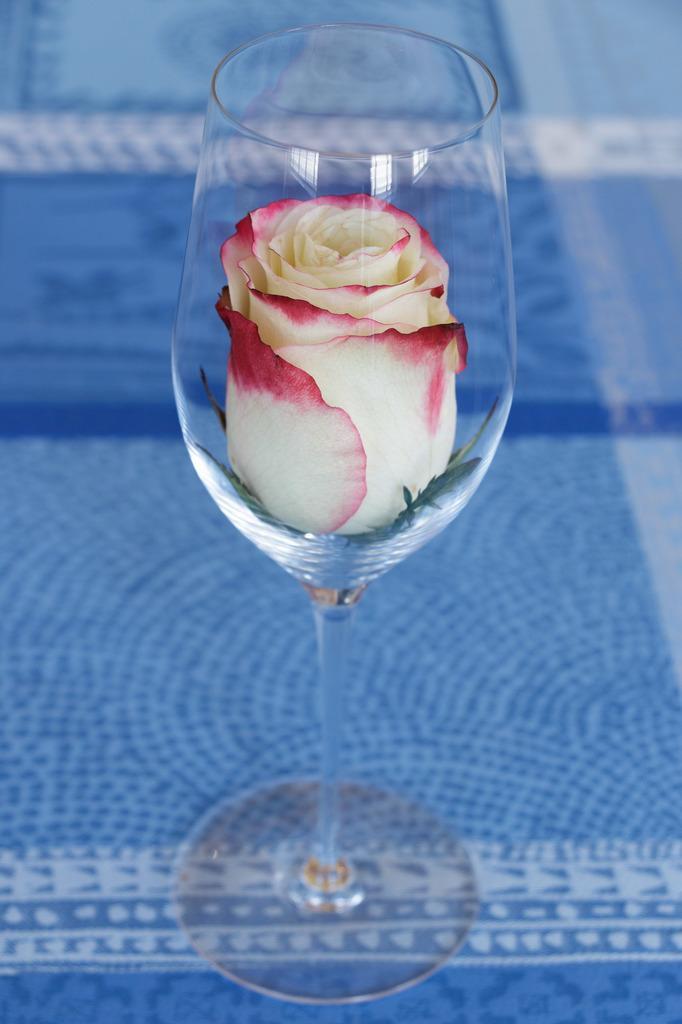Can you describe this image briefly? In the center of the picture there is a glass, in the glass there is a rose flower. The glass is placed on a blue color cloth. 